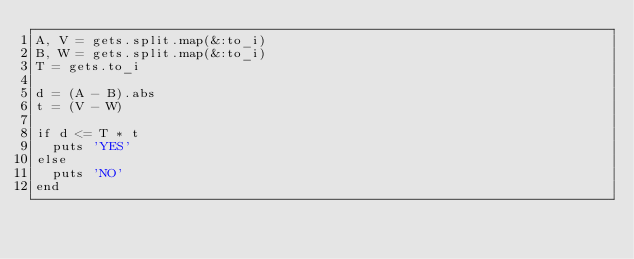Convert code to text. <code><loc_0><loc_0><loc_500><loc_500><_Ruby_>A, V = gets.split.map(&:to_i)
B, W = gets.split.map(&:to_i)
T = gets.to_i

d = (A - B).abs
t = (V - W)

if d <= T * t
  puts 'YES'
else
  puts 'NO'
end
</code> 